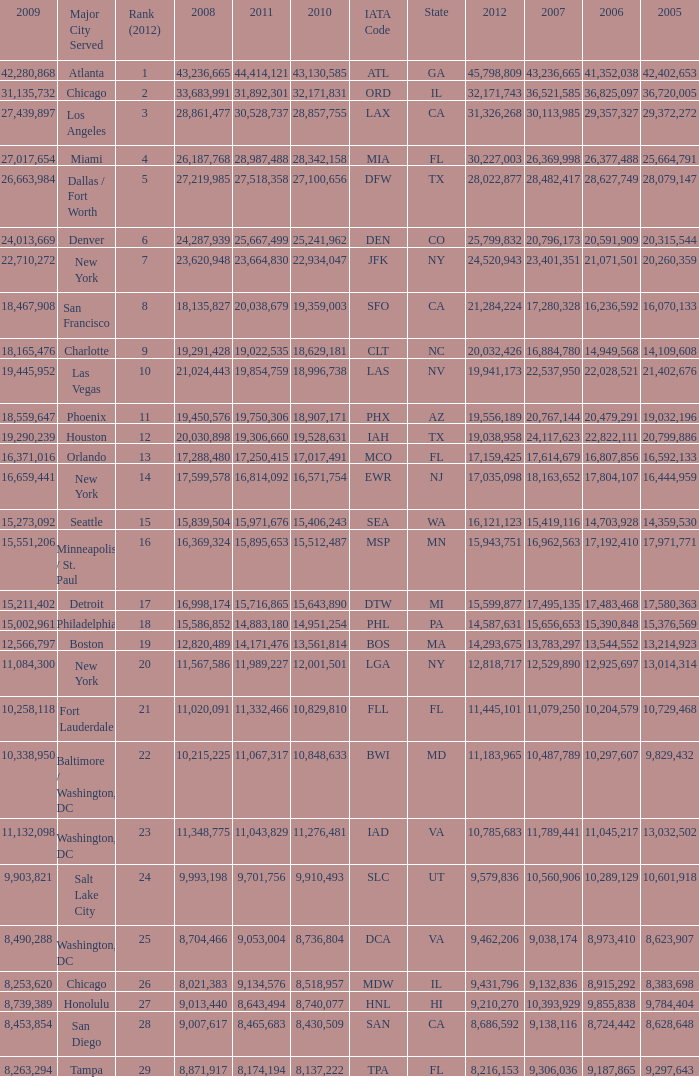Parse the table in full. {'header': ['2009', 'Major City Served', 'Rank (2012)', '2008', '2011', '2010', 'IATA Code', 'State', '2012', '2007', '2006', '2005'], 'rows': [['42,280,868', 'Atlanta', '1', '43,236,665', '44,414,121', '43,130,585', 'ATL', 'GA', '45,798,809', '43,236,665', '41,352,038', '42,402,653'], ['31,135,732', 'Chicago', '2', '33,683,991', '31,892,301', '32,171,831', 'ORD', 'IL', '32,171,743', '36,521,585', '36,825,097', '36,720,005'], ['27,439,897', 'Los Angeles', '3', '28,861,477', '30,528,737', '28,857,755', 'LAX', 'CA', '31,326,268', '30,113,985', '29,357,327', '29,372,272'], ['27,017,654', 'Miami', '4', '26,187,768', '28,987,488', '28,342,158', 'MIA', 'FL', '30,227,003', '26,369,998', '26,377,488', '25,664,791'], ['26,663,984', 'Dallas / Fort Worth', '5', '27,219,985', '27,518,358', '27,100,656', 'DFW', 'TX', '28,022,877', '28,482,417', '28,627,749', '28,079,147'], ['24,013,669', 'Denver', '6', '24,287,939', '25,667,499', '25,241,962', 'DEN', 'CO', '25,799,832', '20,796,173', '20,591,909', '20,315,544'], ['22,710,272', 'New York', '7', '23,620,948', '23,664,830', '22,934,047', 'JFK', 'NY', '24,520,943', '23,401,351', '21,071,501', '20,260,359'], ['18,467,908', 'San Francisco', '8', '18,135,827', '20,038,679', '19,359,003', 'SFO', 'CA', '21,284,224', '17,280,328', '16,236,592', '16,070,133'], ['18,165,476', 'Charlotte', '9', '19,291,428', '19,022,535', '18,629,181', 'CLT', 'NC', '20,032,426', '16,884,780', '14,949,568', '14,109,608'], ['19,445,952', 'Las Vegas', '10', '21,024,443', '19,854,759', '18,996,738', 'LAS', 'NV', '19,941,173', '22,537,950', '22,028,521', '21,402,676'], ['18,559,647', 'Phoenix', '11', '19,450,576', '19,750,306', '18,907,171', 'PHX', 'AZ', '19,556,189', '20,767,144', '20,479,291', '19,032,196'], ['19,290,239', 'Houston', '12', '20,030,898', '19,306,660', '19,528,631', 'IAH', 'TX', '19,038,958', '24,117,623', '22,822,111', '20,799,886'], ['16,371,016', 'Orlando', '13', '17,288,480', '17,250,415', '17,017,491', 'MCO', 'FL', '17,159,425', '17,614,679', '16,807,856', '16,592,133'], ['16,659,441', 'New York', '14', '17,599,578', '16,814,092', '16,571,754', 'EWR', 'NJ', '17,035,098', '18,163,652', '17,804,107', '16,444,959'], ['15,273,092', 'Seattle', '15', '15,839,504', '15,971,676', '15,406,243', 'SEA', 'WA', '16,121,123', '15,419,116', '14,703,928', '14,359,530'], ['15,551,206', 'Minneapolis / St. Paul', '16', '16,369,324', '15,895,653', '15,512,487', 'MSP', 'MN', '15,943,751', '16,962,563', '17,192,410', '17,971,771'], ['15,211,402', 'Detroit', '17', '16,998,174', '15,716,865', '15,643,890', 'DTW', 'MI', '15,599,877', '17,495,135', '17,483,468', '17,580,363'], ['15,002,961', 'Philadelphia', '18', '15,586,852', '14,883,180', '14,951,254', 'PHL', 'PA', '14,587,631', '15,656,653', '15,390,848', '15,376,569'], ['12,566,797', 'Boston', '19', '12,820,489', '14,171,476', '13,561,814', 'BOS', 'MA', '14,293,675', '13,783,297', '13,544,552', '13,214,923'], ['11,084,300', 'New York', '20', '11,567,586', '11,989,227', '12,001,501', 'LGA', 'NY', '12,818,717', '12,529,890', '12,925,697', '13,014,314'], ['10,258,118', 'Fort Lauderdale', '21', '11,020,091', '11,332,466', '10,829,810', 'FLL', 'FL', '11,445,101', '11,079,250', '10,204,579', '10,729,468'], ['10,338,950', 'Baltimore / Washington, DC', '22', '10,215,225', '11,067,317', '10,848,633', 'BWI', 'MD', '11,183,965', '10,487,789', '10,297,607', '9,829,432'], ['11,132,098', 'Washington, DC', '23', '11,348,775', '11,043,829', '11,276,481', 'IAD', 'VA', '10,785,683', '11,789,441', '11,045,217', '13,032,502'], ['9,903,821', 'Salt Lake City', '24', '9,993,198', '9,701,756', '9,910,493', 'SLC', 'UT', '9,579,836', '10,560,906', '10,289,129', '10,601,918'], ['8,490,288', 'Washington, DC', '25', '8,704,466', '9,053,004', '8,736,804', 'DCA', 'VA', '9,462,206', '9,038,174', '8,973,410', '8,623,907'], ['8,253,620', 'Chicago', '26', '8,021,383', '9,134,576', '8,518,957', 'MDW', 'IL', '9,431,796', '9,132,836', '8,915,292', '8,383,698'], ['8,739,389', 'Honolulu', '27', '9,013,440', '8,643,494', '8,740,077', 'HNL', 'HI', '9,210,270', '10,393,929', '9,855,838', '9,784,404'], ['8,453,854', 'San Diego', '28', '9,007,617', '8,465,683', '8,430,509', 'SAN', 'CA', '8,686,592', '9,138,116', '8,724,442', '8,628,648'], ['8,263,294', 'Tampa', '29', '8,871,917', '8,174,194', '8,137,222', 'TPA', 'FL', '8,216,153', '9,306,036', '9,187,865', '9,297,643']]} When Philadelphia has a 2007 less than 20,796,173 and a 2008 more than 10,215,225, what is the smallest 2009? 15002961.0. 